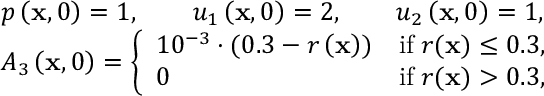<formula> <loc_0><loc_0><loc_500><loc_500>\begin{array} { r l } & { p \left ( x , 0 \right ) = 1 , \quad u _ { 1 } \left ( x , 0 \right ) = 2 , \quad u _ { 2 } \left ( x , 0 \right ) = 1 , } \\ & { A _ { 3 } \left ( x , 0 \right ) = \left \{ \begin{array} { l c } { 1 0 ^ { - 3 } \cdot ( 0 . 3 - r \left ( x \right ) ) } & { i f \, r ( x ) \leq 0 . 3 , } \\ { 0 } & { i f \, r ( x ) > 0 . 3 , } \end{array} } \end{array}</formula> 